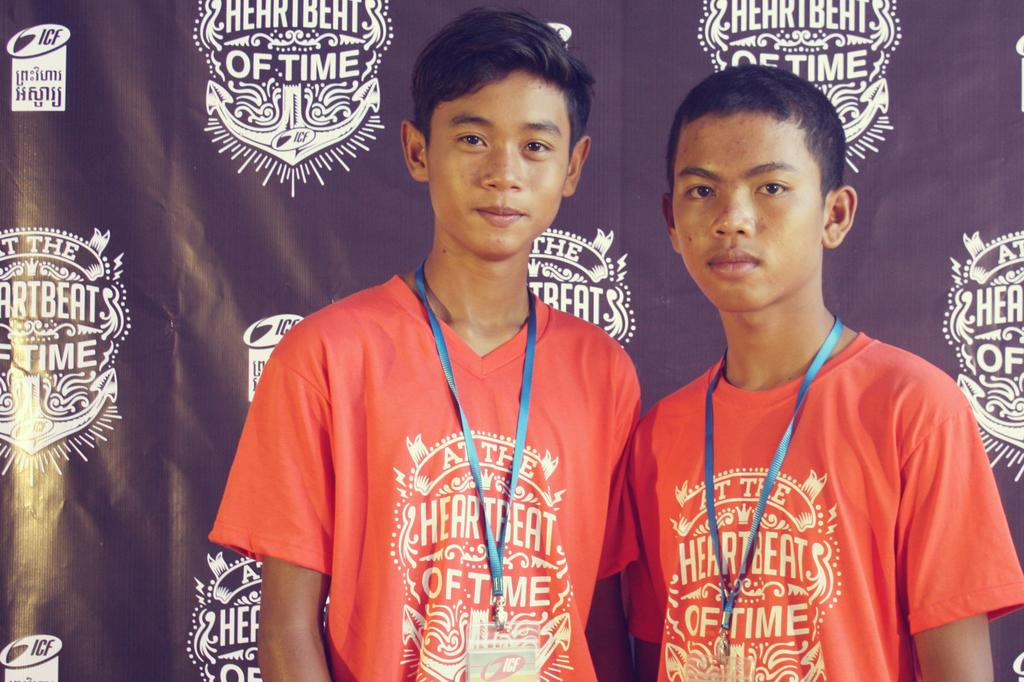<image>
Give a short and clear explanation of the subsequent image. Two men wearing orange T shirts reading Heartbeat 